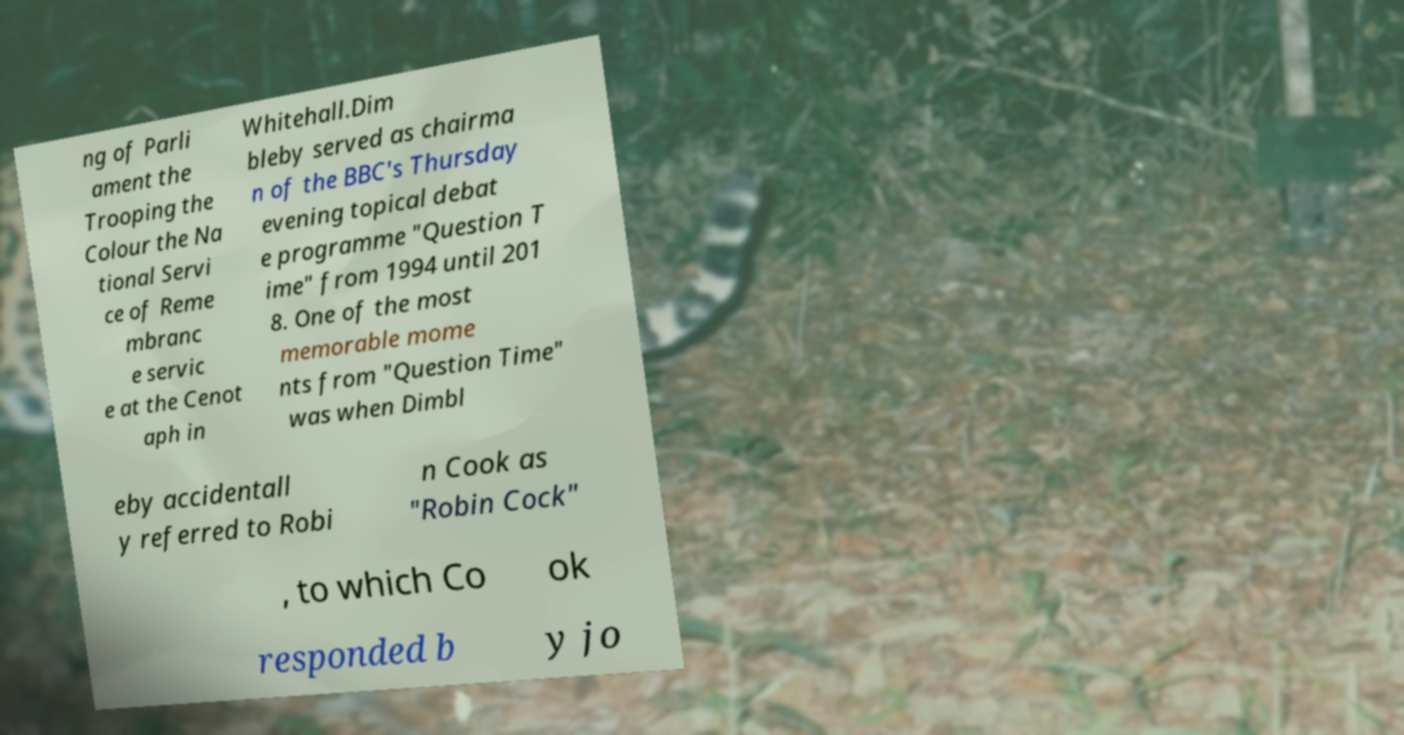Can you read and provide the text displayed in the image?This photo seems to have some interesting text. Can you extract and type it out for me? ng of Parli ament the Trooping the Colour the Na tional Servi ce of Reme mbranc e servic e at the Cenot aph in Whitehall.Dim bleby served as chairma n of the BBC's Thursday evening topical debat e programme "Question T ime" from 1994 until 201 8. One of the most memorable mome nts from "Question Time" was when Dimbl eby accidentall y referred to Robi n Cook as "Robin Cock" , to which Co ok responded b y jo 